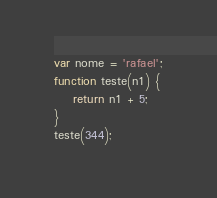<code> <loc_0><loc_0><loc_500><loc_500><_JavaScript_>var nome = 'rafael';
function teste(n1) {
    return n1 + 5;
}
teste(344);
</code> 